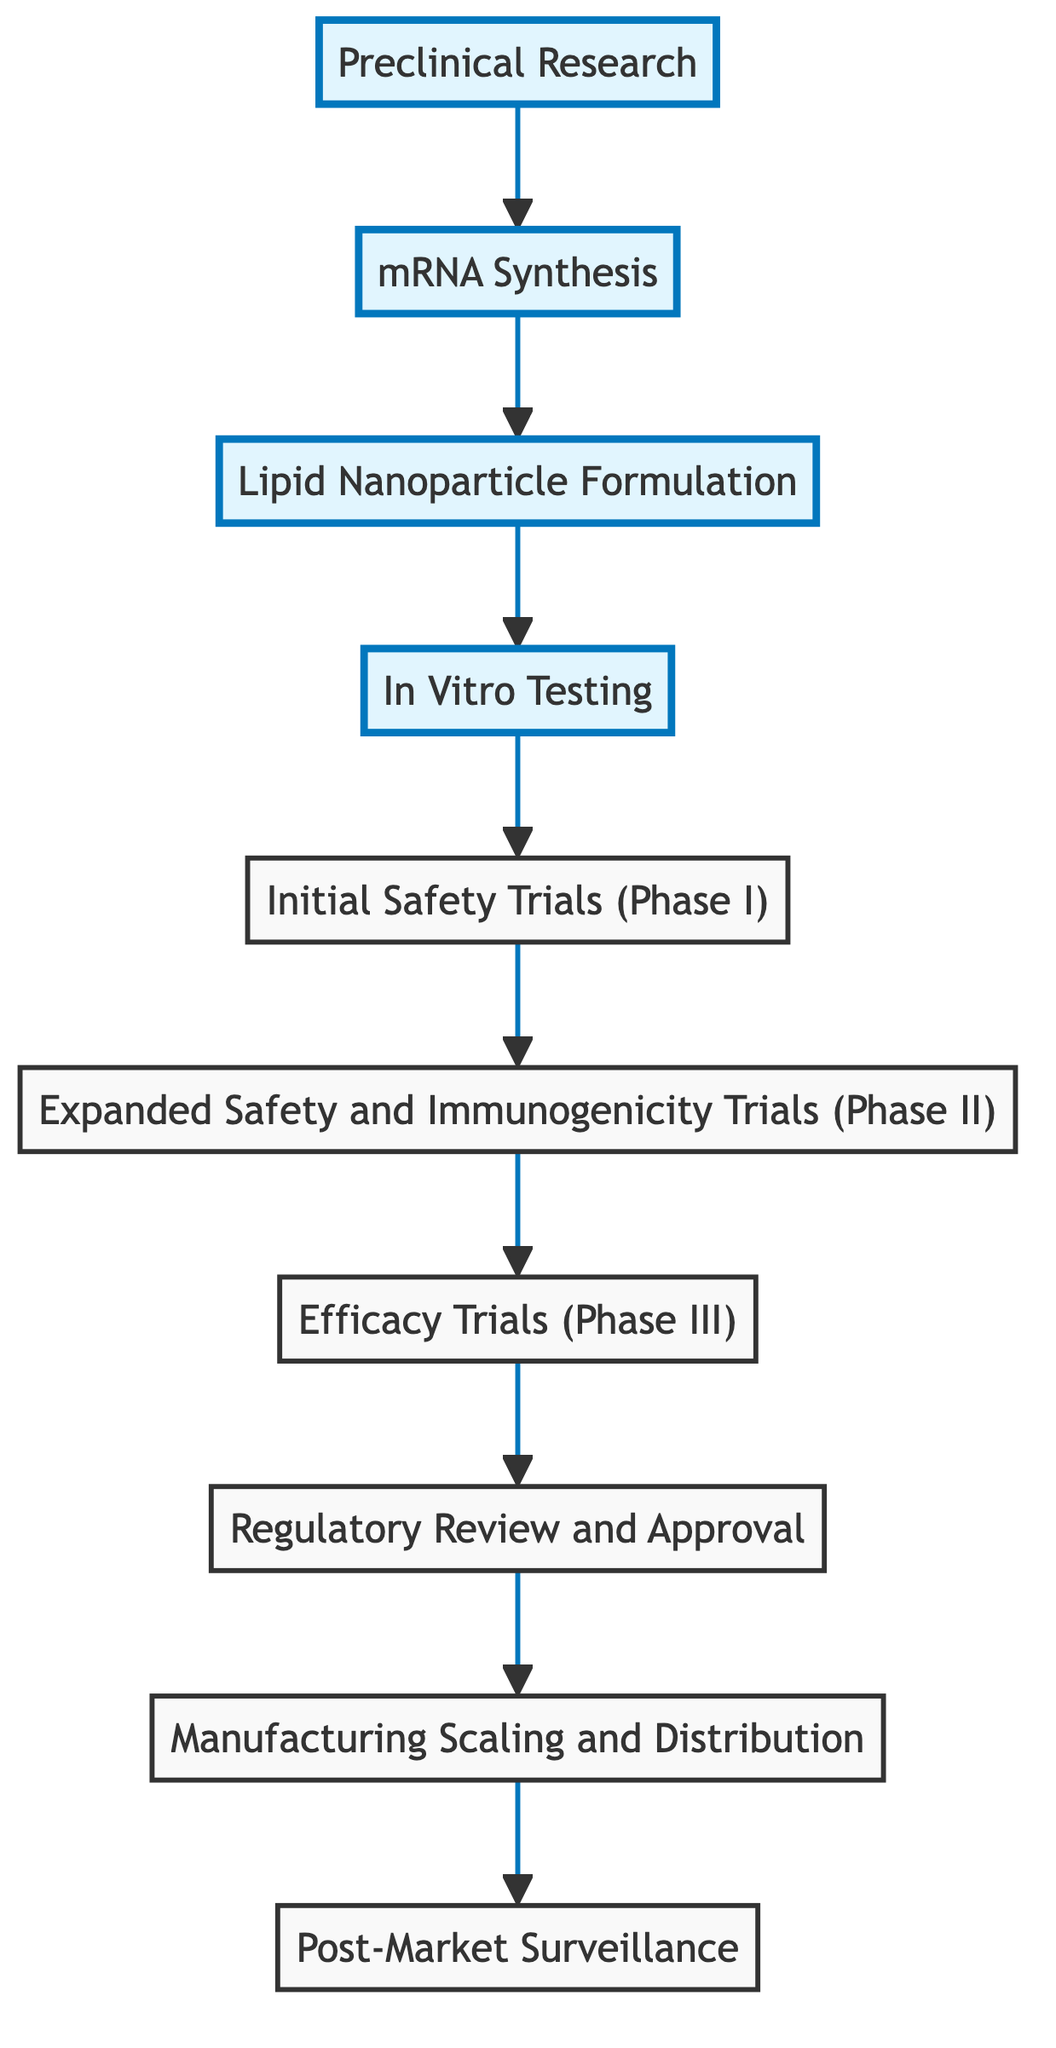What is the last step in the mRNA vaccine production process? The last step listed in the diagram is "Post-Market Surveillance," which is indicated as the final node without a next connection.
Answer: Post-Market Surveillance Which step follows "Lipid Nanoparticle Formulation"? According to the flowchart, "In Vitro Testing" directly follows "Lipid Nanoparticle Formulation," indicating the sequential progression in vaccine development.
Answer: In Vitro Testing How many total steps are shown in the process? Counting all the individual steps represented in the diagram, there are ten distinct nodes detailing each phase in the mRNA vaccine production process.
Answer: Ten What is the primary focus of the "Initial Safety Trials (Phase I)"? The description for this node indicates it is focused on evaluating the safety and dosage in a small group of volunteers, providing insight into the purpose of this testing phase.
Answer: Safety and dosage What occurs after "Regulatory Review and Approval"? Following the "Regulatory Review and Approval" phase, the next step listed is "Manufacturing Scaling and Distribution," indicating the progression towards broader vaccine distribution.
Answer: Manufacturing Scaling and Distribution How does "Expanded Safety and Immunogenicity Trials (Phase II)" relate to the prior step? This phase builds on the "Initial Safety Trials (Phase I)" by involving a larger group of participants to further assess safety, dosage levels, and immune response, demonstrating a progression in study scale and goals.
Answer: Larger group assessment Which step involves the encapsulation of mRNA? The diagram explicitly states that "Lipid Nanoparticle Formulation" is the step that involves encapsulating mRNA in lipid nanoparticles for enhanced stability and delivery.
Answer: Lipid Nanoparticle Formulation What is validated during "In Vitro Testing"? The primary purpose of "In Vitro Testing" is to assess mRNA constructs in cell cultures to validate their expression and immunogenicity, indicating this step's focus on the biological response.
Answer: Expression and immunogenicity What is the overall goal of "Efficacy Trials (Phase III)"? The goal of this phase is to assess the vaccine’s efficacy in preventing disease among a diverse population, which is critical for demonstrating the vaccine's practical effectiveness.
Answer: Vaccine efficacy prevention 